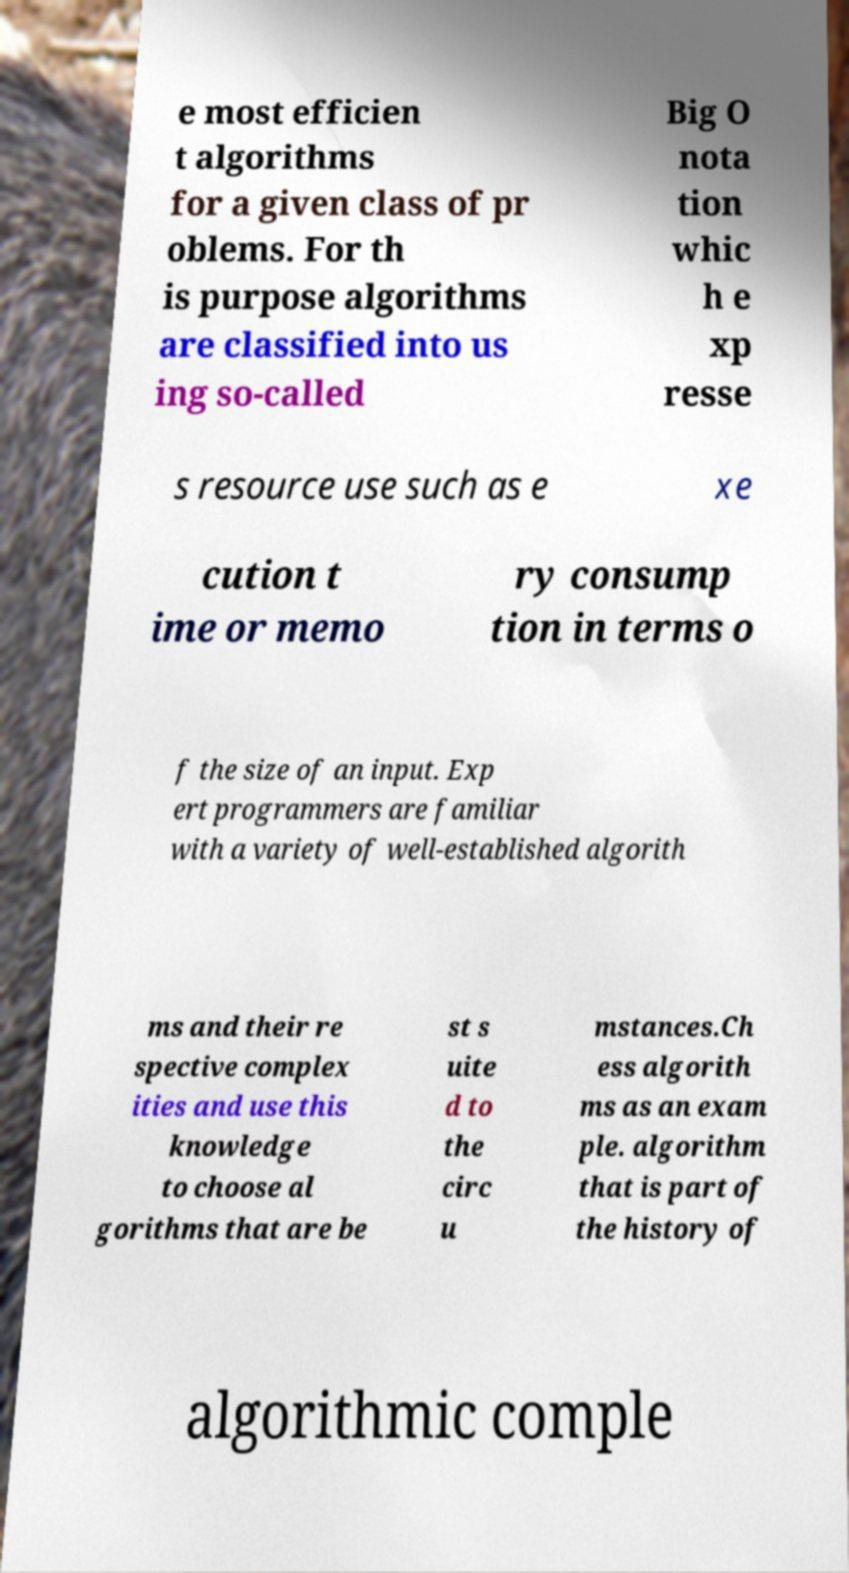Can you read and provide the text displayed in the image?This photo seems to have some interesting text. Can you extract and type it out for me? e most efficien t algorithms for a given class of pr oblems. For th is purpose algorithms are classified into us ing so-called Big O nota tion whic h e xp resse s resource use such as e xe cution t ime or memo ry consump tion in terms o f the size of an input. Exp ert programmers are familiar with a variety of well-established algorith ms and their re spective complex ities and use this knowledge to choose al gorithms that are be st s uite d to the circ u mstances.Ch ess algorith ms as an exam ple. algorithm that is part of the history of algorithmic comple 